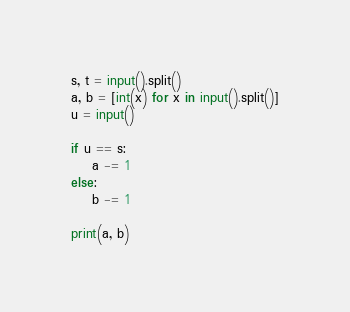Convert code to text. <code><loc_0><loc_0><loc_500><loc_500><_Python_>s, t = input().split()
a, b = [int(x) for x in input().split()]
u = input()

if u == s:
    a -= 1
else:
    b -= 1

print(a, b)</code> 